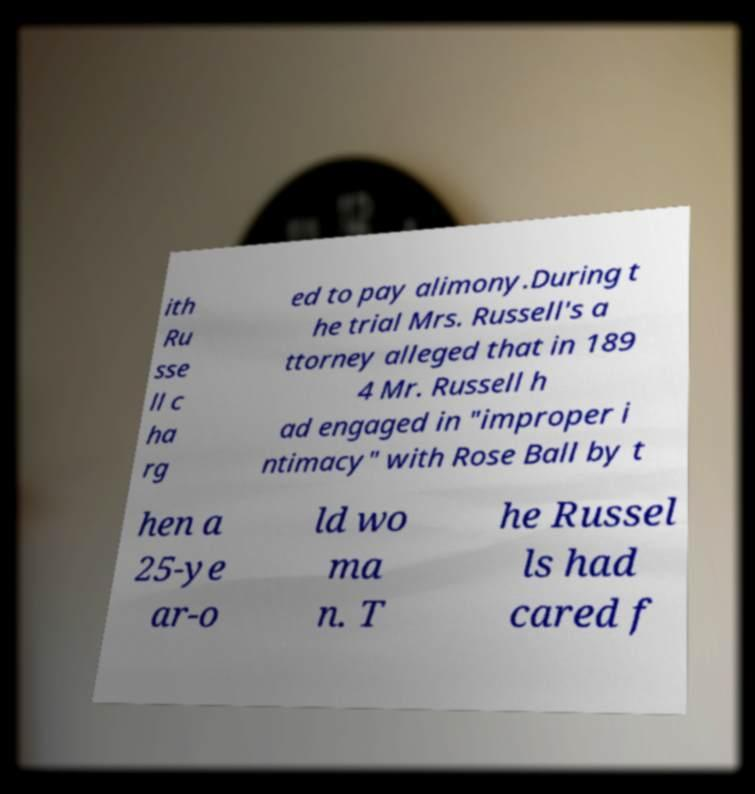Could you assist in decoding the text presented in this image and type it out clearly? ith Ru sse ll c ha rg ed to pay alimony.During t he trial Mrs. Russell's a ttorney alleged that in 189 4 Mr. Russell h ad engaged in "improper i ntimacy" with Rose Ball by t hen a 25-ye ar-o ld wo ma n. T he Russel ls had cared f 